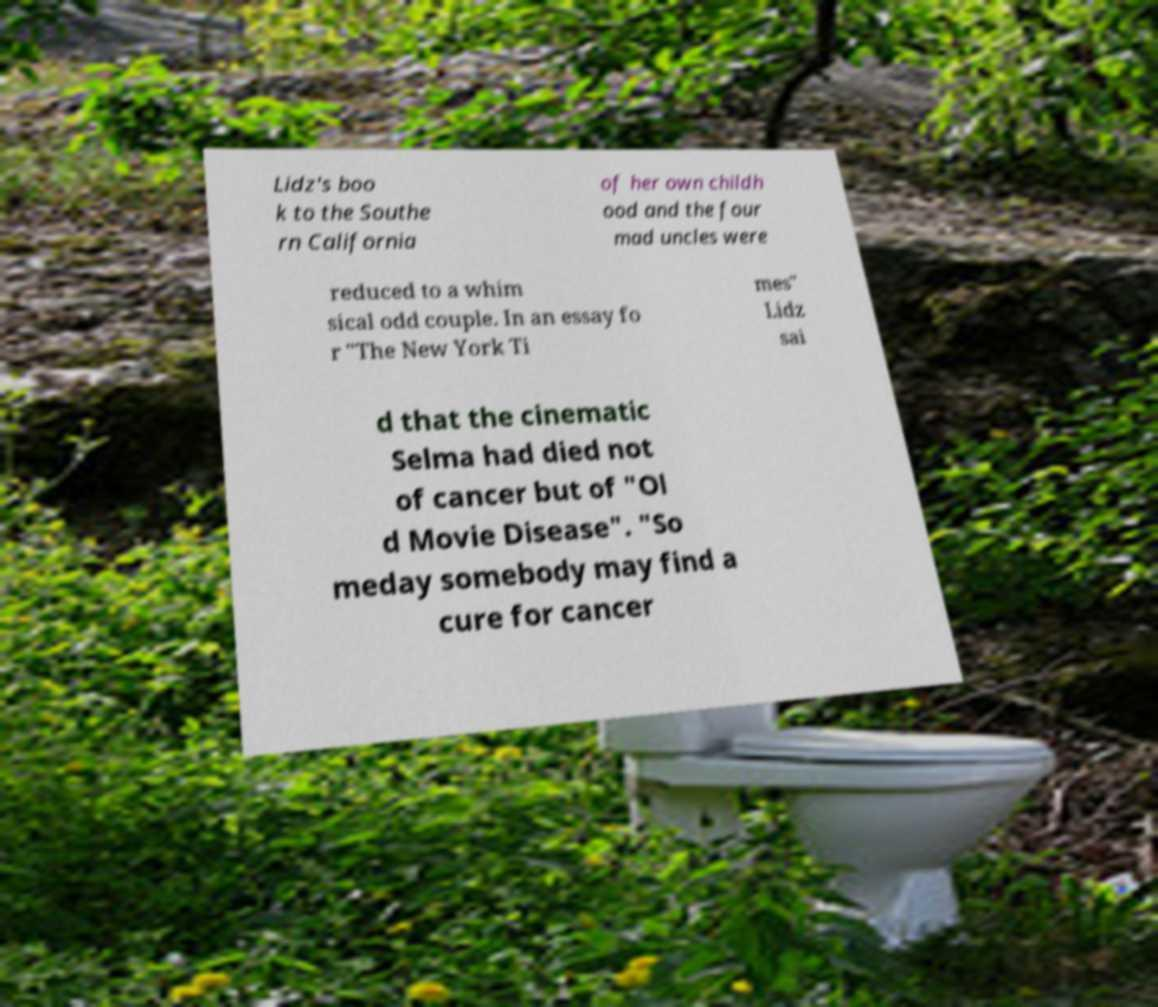Please identify and transcribe the text found in this image. Lidz's boo k to the Southe rn California of her own childh ood and the four mad uncles were reduced to a whim sical odd couple. In an essay fo r "The New York Ti mes" Lidz sai d that the cinematic Selma had died not of cancer but of "Ol d Movie Disease". "So meday somebody may find a cure for cancer 